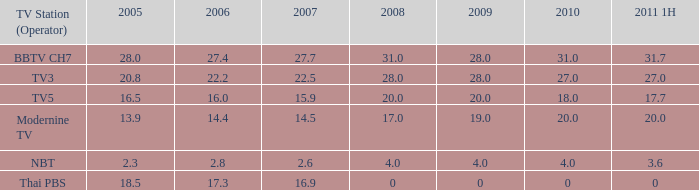How many 2011 1H values have a 2006 of 27.4 and 2007 over 27.7? 0.0. 